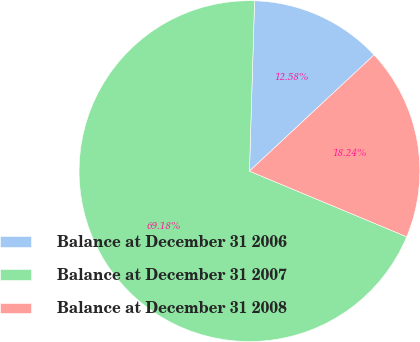Convert chart to OTSL. <chart><loc_0><loc_0><loc_500><loc_500><pie_chart><fcel>Balance at December 31 2006<fcel>Balance at December 31 2007<fcel>Balance at December 31 2008<nl><fcel>12.58%<fcel>69.18%<fcel>18.24%<nl></chart> 